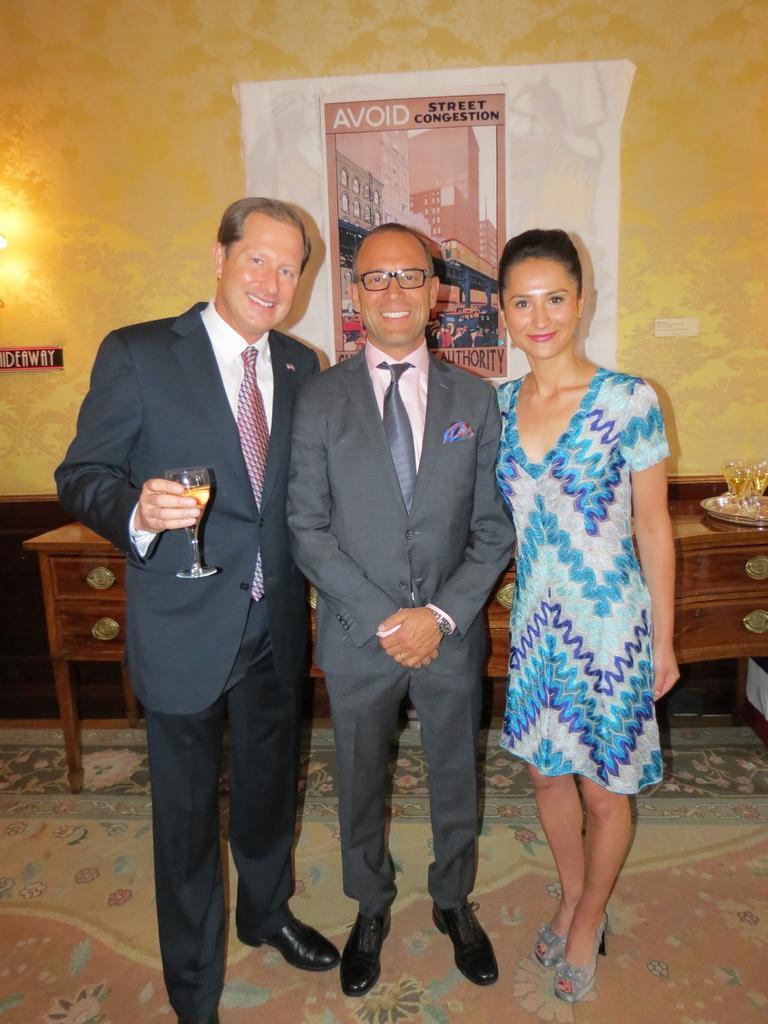Could you give a brief overview of what you see in this image? In the center of the image there are three people standing. At the bottom of the image there is carpet. In the background of the image there is wall. There is a poster with some text. There is a table. 